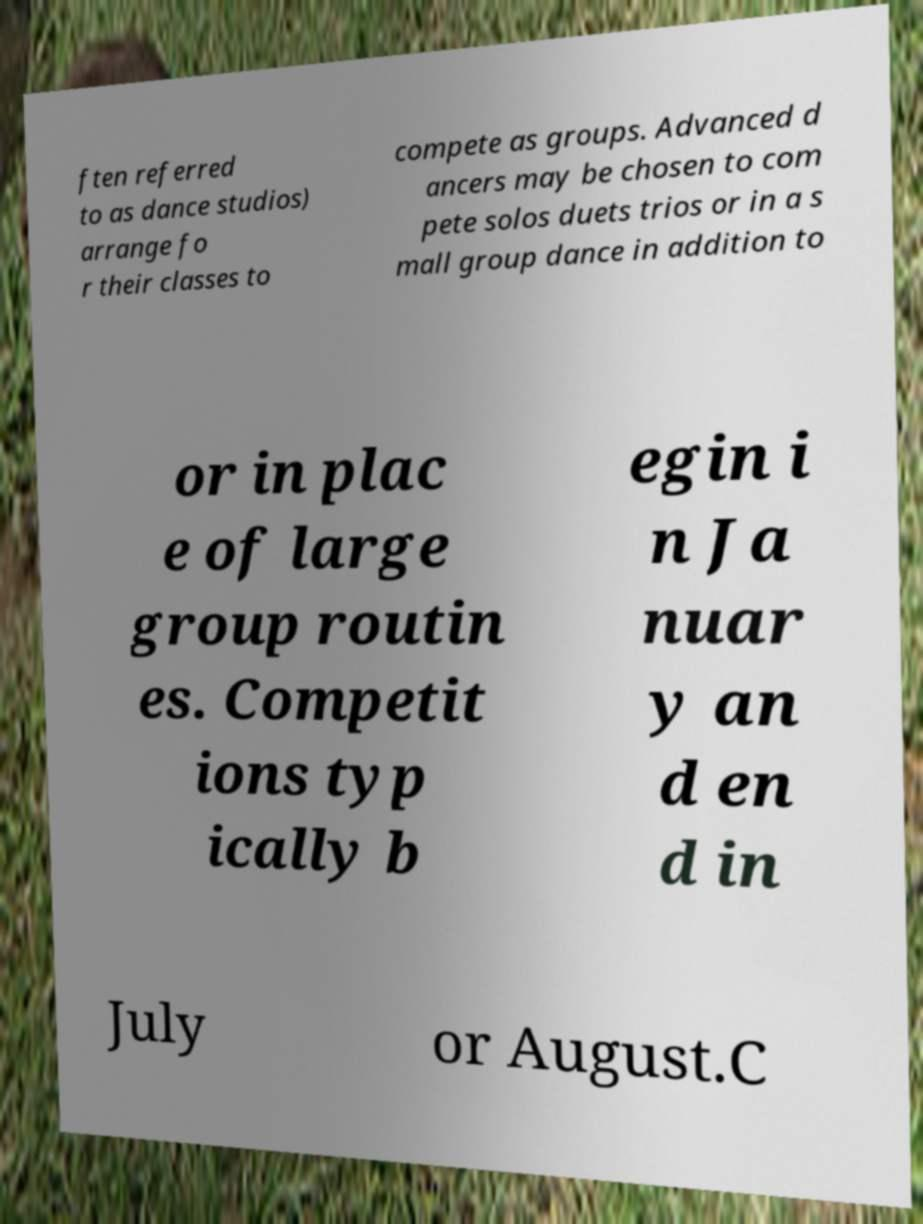Can you read and provide the text displayed in the image?This photo seems to have some interesting text. Can you extract and type it out for me? ften referred to as dance studios) arrange fo r their classes to compete as groups. Advanced d ancers may be chosen to com pete solos duets trios or in a s mall group dance in addition to or in plac e of large group routin es. Competit ions typ ically b egin i n Ja nuar y an d en d in July or August.C 